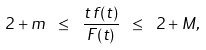Convert formula to latex. <formula><loc_0><loc_0><loc_500><loc_500>2 + m \ \leq \ \frac { t \, f ( t ) } { F ( t ) } \ \leq \ 2 + M ,</formula> 